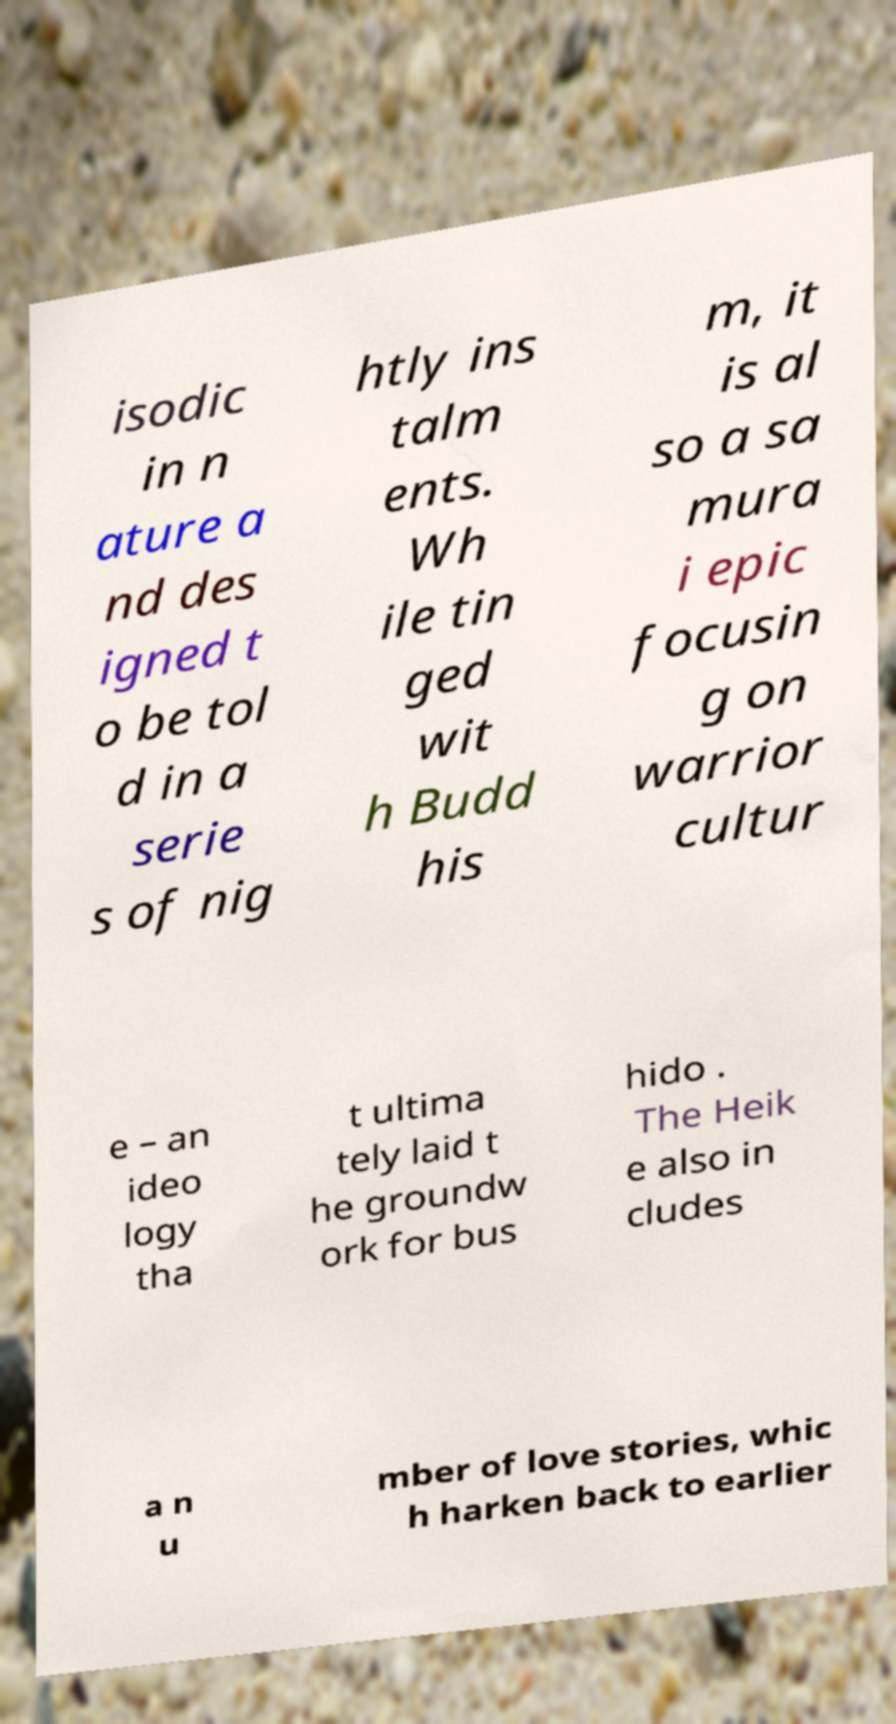Please identify and transcribe the text found in this image. isodic in n ature a nd des igned t o be tol d in a serie s of nig htly ins talm ents. Wh ile tin ged wit h Budd his m, it is al so a sa mura i epic focusin g on warrior cultur e – an ideo logy tha t ultima tely laid t he groundw ork for bus hido . The Heik e also in cludes a n u mber of love stories, whic h harken back to earlier 